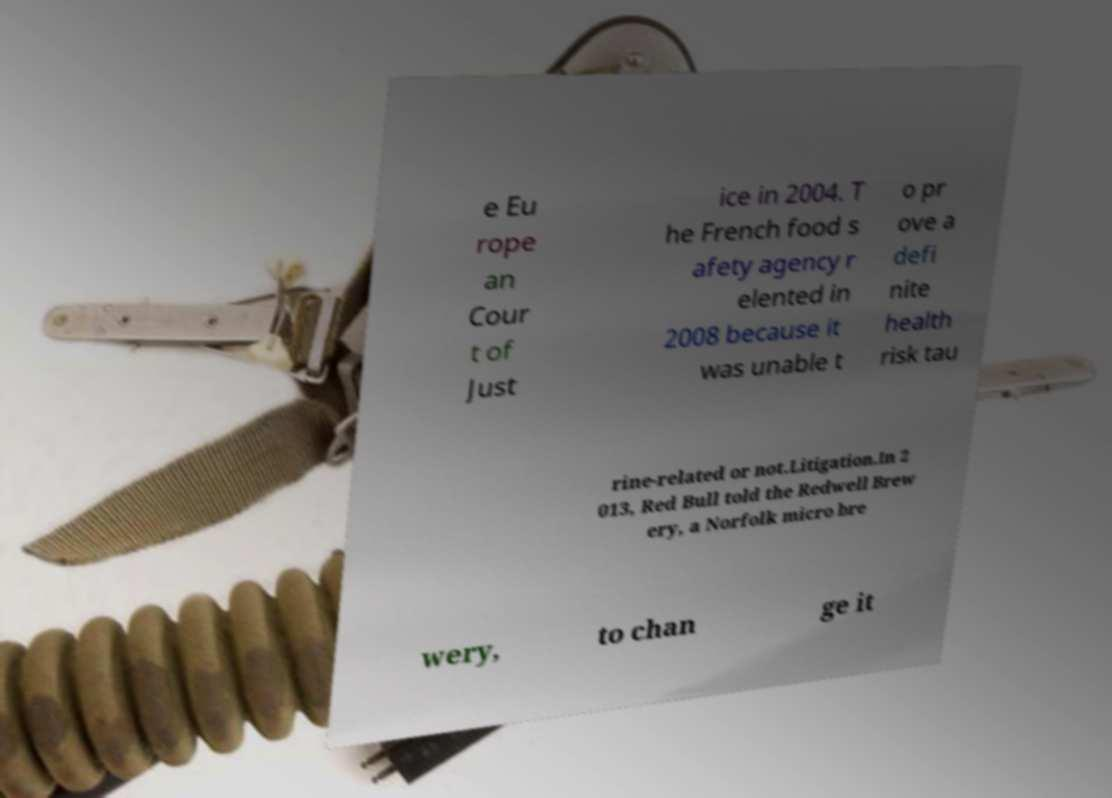Could you assist in decoding the text presented in this image and type it out clearly? e Eu rope an Cour t of Just ice in 2004. T he French food s afety agency r elented in 2008 because it was unable t o pr ove a defi nite health risk tau rine-related or not.Litigation.In 2 013, Red Bull told the Redwell Brew ery, a Norfolk micro bre wery, to chan ge it 